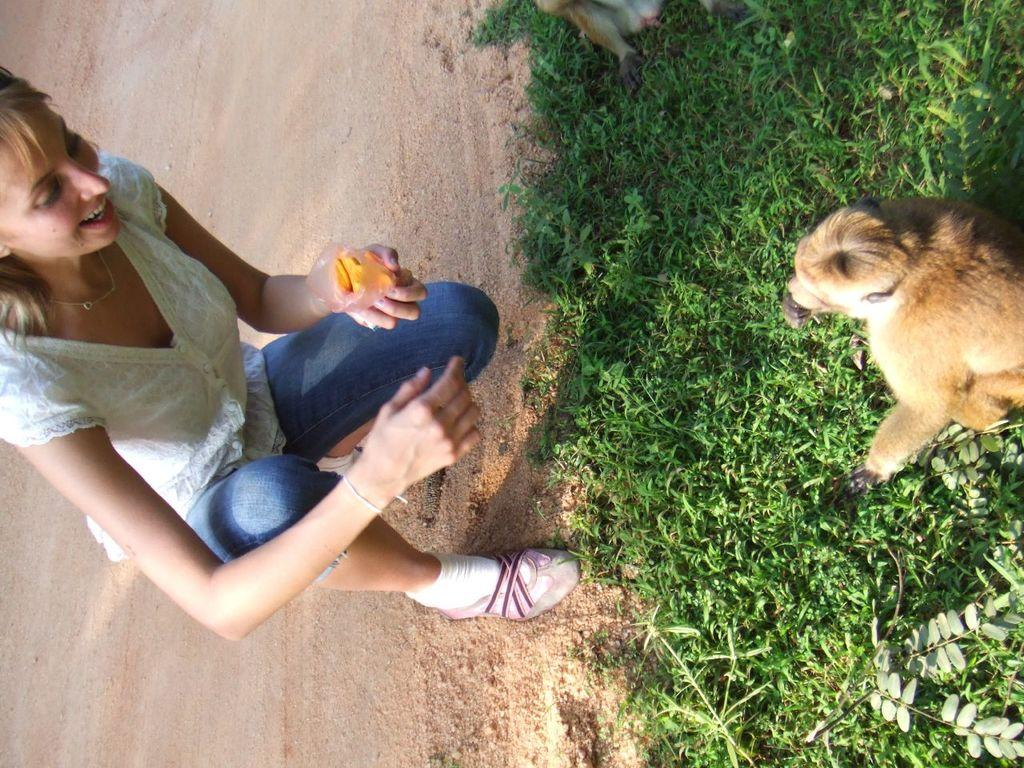Who is present in the image? There is a lady in the image. What is the lady holding in her hand? The lady is holding an object in her hand. What type of animals can be seen in the image? There are animals in the image. What is the terrain like in the image? There is grassy land in the image. Can you identify any plants in the image? Yes, there is a plant in the image. What is the purpose of the lady's humorous kiss in the image? There is no indication of a humorous kiss in the image, as the facts provided do not mention any such action. 